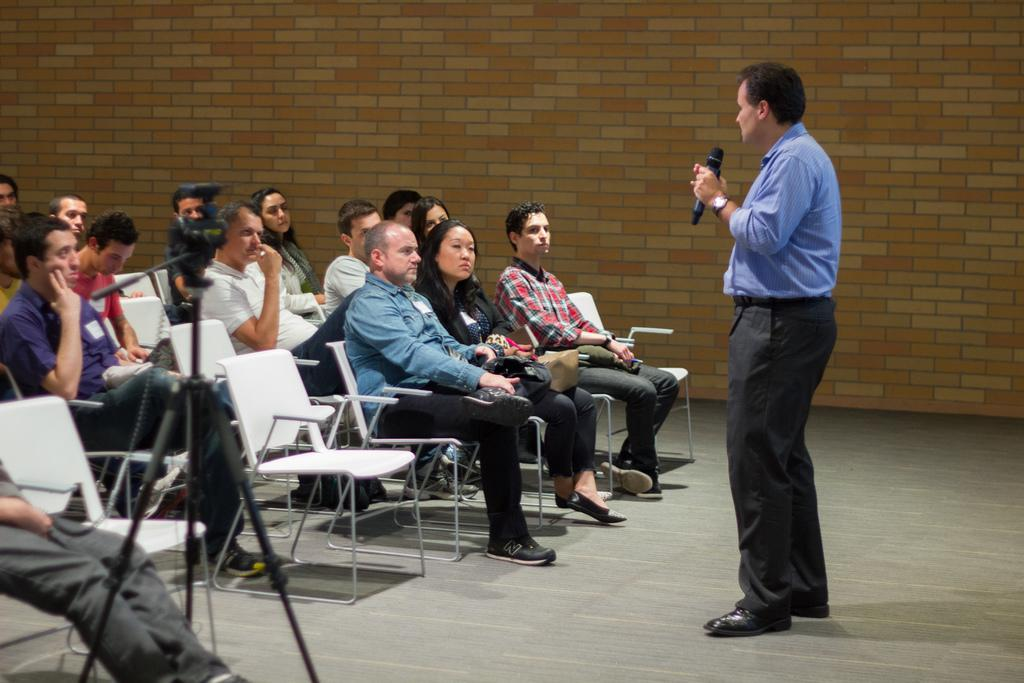What are the people in the image doing? There is a group of people sitting in the image. Where are the people sitting? The people are sitting in a chair. What equipment can be seen in the image? There is a camera fixed to a tripod stand in the image. What is the man in the image doing? The man is standing in the image and talking into a microphone. What type of holiday is being celebrated in the image? There is no indication of a holiday being celebrated in the image. Can you see a maid in the image? There is no maid present in the image. 